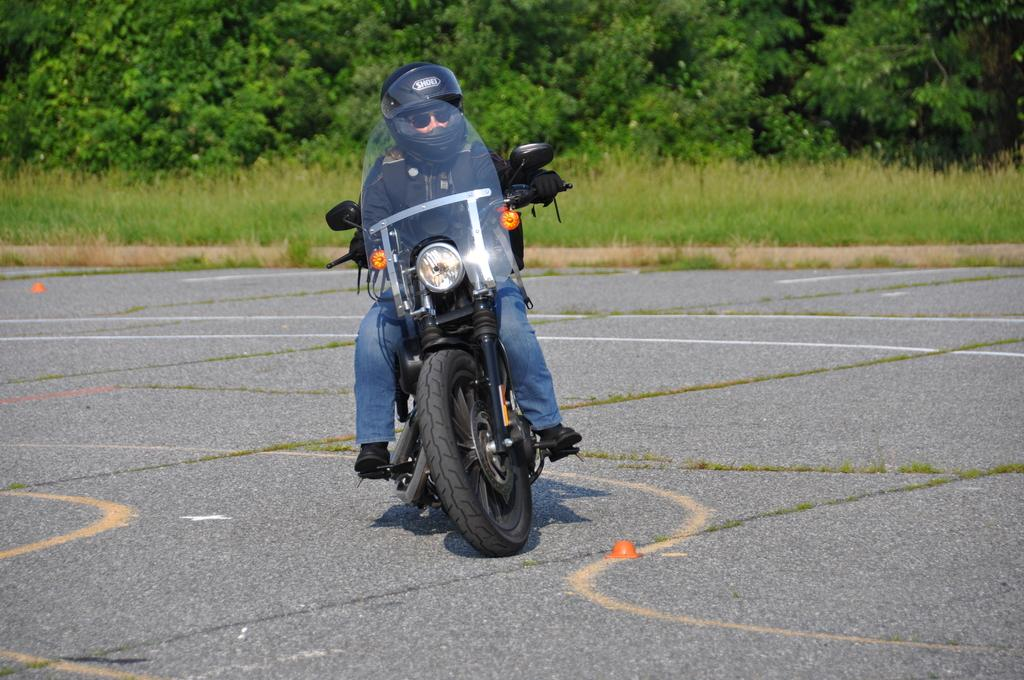What is the main subject of the image? There is a person riding a bike in the image. What is the person wearing? The person is wearing a black jacket and blue pants. What can be seen in the background of the image? There is grass and trees in the background of the image. What is the color of the trees? The trees are green in color. What type of prose can be heard being read by the person riding the bike in the image? There is no indication in the image that the person is reading or listening to any prose. How many cakes are visible on the bike in the image? There are no cakes present in the image; it only features a person riding a bike. 